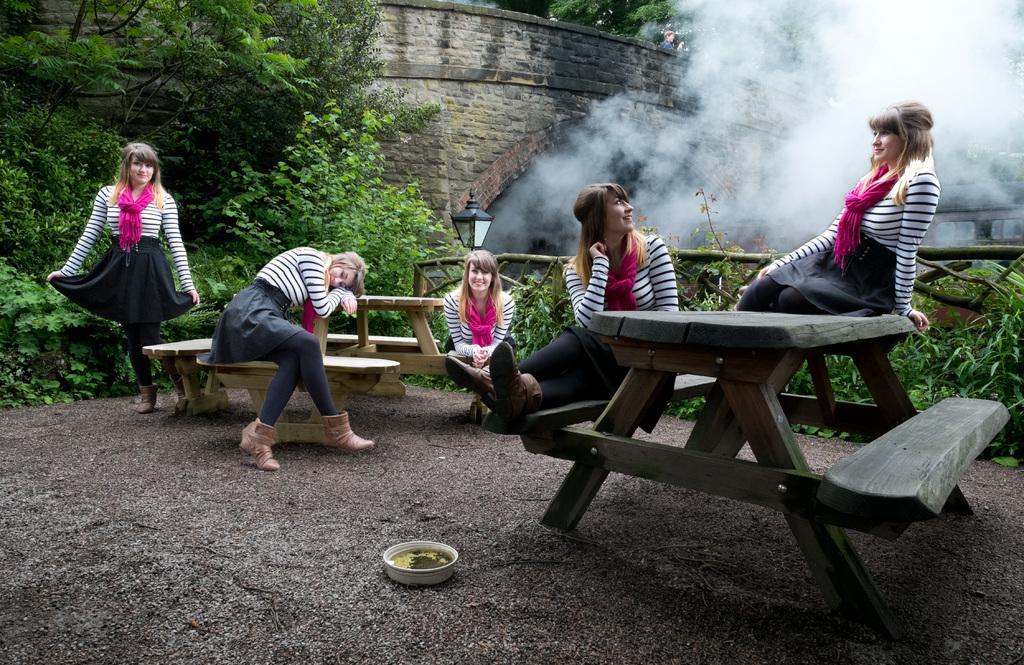In one or two sentences, can you explain what this image depicts? The image consist of a lady with duplicate images of her in various positions sitting,standing on bench and in background there are trees and from tunnel smoke is coming out. 